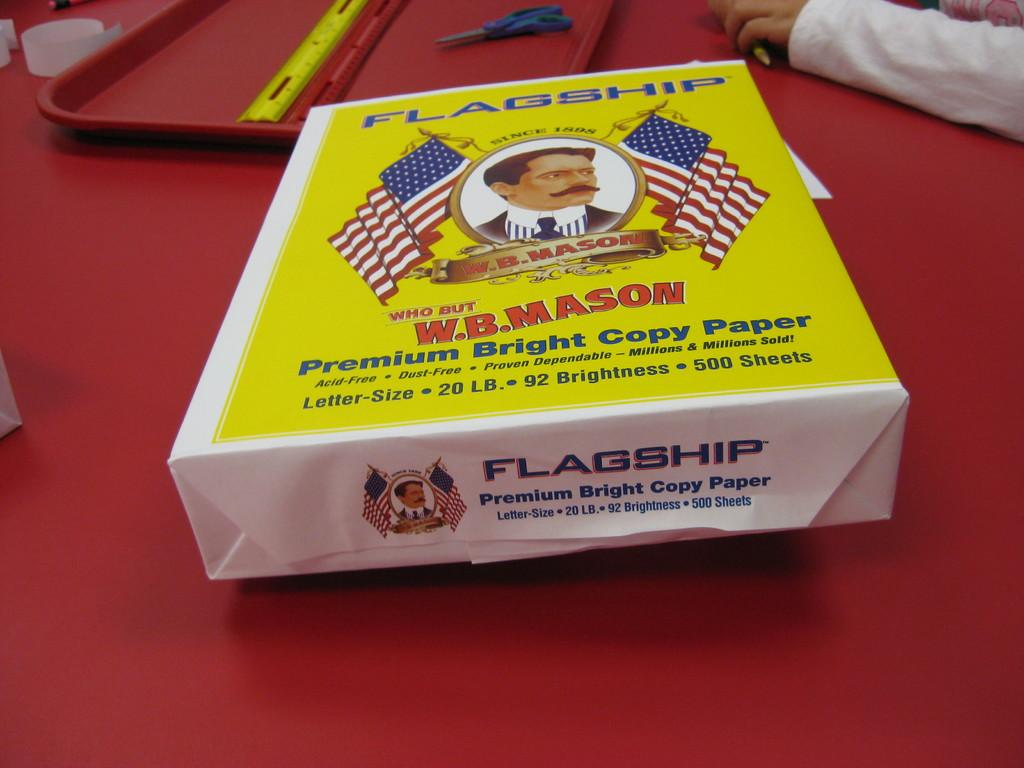<image>
Give a short and clear explanation of the subsequent image. Ream of copy paper made by Flagship focusing on W.B. Mason 